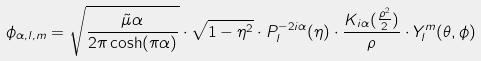<formula> <loc_0><loc_0><loc_500><loc_500>\phi _ { \alpha , l , m } = \sqrt { \frac { \tilde { \mu } \alpha } { 2 \pi \cosh ( \pi \alpha ) } } \cdot \sqrt { 1 - \eta ^ { 2 } } \cdot P _ { l } ^ { - 2 i \alpha } ( \eta ) \cdot \frac { K _ { i \alpha } ( \frac { \rho ^ { 2 } } { 2 } ) } { \rho } \cdot Y _ { l } ^ { m } ( \theta , \phi )</formula> 